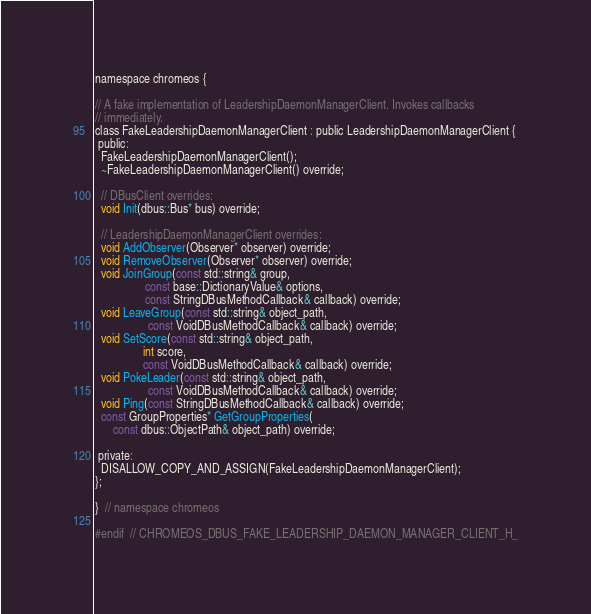<code> <loc_0><loc_0><loc_500><loc_500><_C_>
namespace chromeos {

// A fake implementation of LeadershipDaemonManagerClient. Invokes callbacks
// immediately.
class FakeLeadershipDaemonManagerClient : public LeadershipDaemonManagerClient {
 public:
  FakeLeadershipDaemonManagerClient();
  ~FakeLeadershipDaemonManagerClient() override;

  // DBusClient overrides:
  void Init(dbus::Bus* bus) override;

  // LeadershipDaemonManagerClient overrides:
  void AddObserver(Observer* observer) override;
  void RemoveObserver(Observer* observer) override;
  void JoinGroup(const std::string& group,
                 const base::DictionaryValue& options,
                 const StringDBusMethodCallback& callback) override;
  void LeaveGroup(const std::string& object_path,
                  const VoidDBusMethodCallback& callback) override;
  void SetScore(const std::string& object_path,
                int score,
                const VoidDBusMethodCallback& callback) override;
  void PokeLeader(const std::string& object_path,
                  const VoidDBusMethodCallback& callback) override;
  void Ping(const StringDBusMethodCallback& callback) override;
  const GroupProperties* GetGroupProperties(
      const dbus::ObjectPath& object_path) override;

 private:
  DISALLOW_COPY_AND_ASSIGN(FakeLeadershipDaemonManagerClient);
};

}  // namespace chromeos

#endif  // CHROMEOS_DBUS_FAKE_LEADERSHIP_DAEMON_MANAGER_CLIENT_H_
</code> 